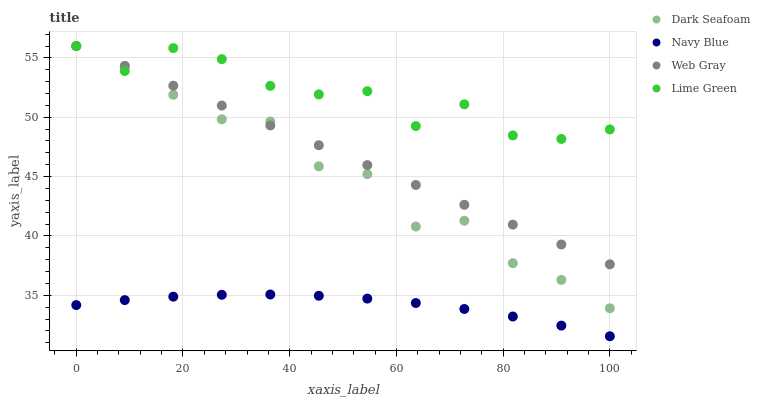Does Navy Blue have the minimum area under the curve?
Answer yes or no. Yes. Does Lime Green have the maximum area under the curve?
Answer yes or no. Yes. Does Dark Seafoam have the minimum area under the curve?
Answer yes or no. No. Does Dark Seafoam have the maximum area under the curve?
Answer yes or no. No. Is Web Gray the smoothest?
Answer yes or no. Yes. Is Lime Green the roughest?
Answer yes or no. Yes. Is Dark Seafoam the smoothest?
Answer yes or no. No. Is Dark Seafoam the roughest?
Answer yes or no. No. Does Navy Blue have the lowest value?
Answer yes or no. Yes. Does Dark Seafoam have the lowest value?
Answer yes or no. No. Does Lime Green have the highest value?
Answer yes or no. Yes. Is Navy Blue less than Dark Seafoam?
Answer yes or no. Yes. Is Web Gray greater than Navy Blue?
Answer yes or no. Yes. Does Web Gray intersect Dark Seafoam?
Answer yes or no. Yes. Is Web Gray less than Dark Seafoam?
Answer yes or no. No. Is Web Gray greater than Dark Seafoam?
Answer yes or no. No. Does Navy Blue intersect Dark Seafoam?
Answer yes or no. No. 